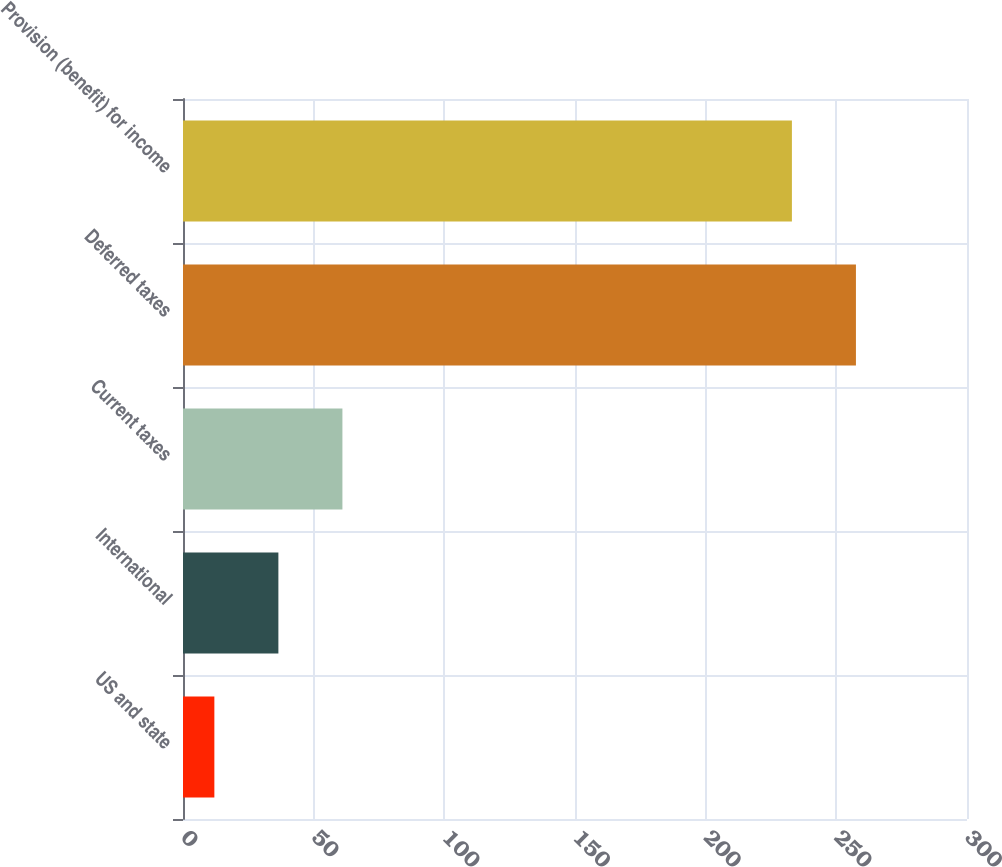<chart> <loc_0><loc_0><loc_500><loc_500><bar_chart><fcel>US and state<fcel>International<fcel>Current taxes<fcel>Deferred taxes<fcel>Provision (benefit) for income<nl><fcel>12<fcel>36.5<fcel>61<fcel>257.5<fcel>233<nl></chart> 